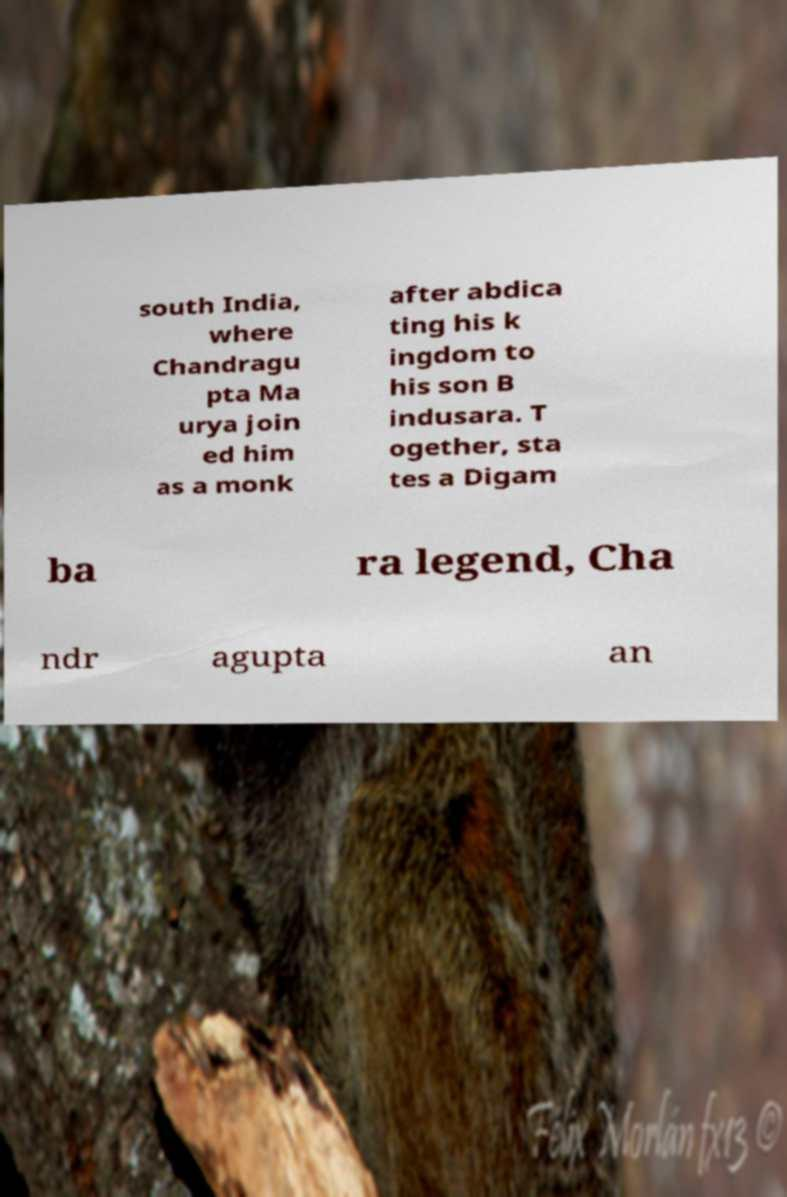There's text embedded in this image that I need extracted. Can you transcribe it verbatim? south India, where Chandragu pta Ma urya join ed him as a monk after abdica ting his k ingdom to his son B indusara. T ogether, sta tes a Digam ba ra legend, Cha ndr agupta an 